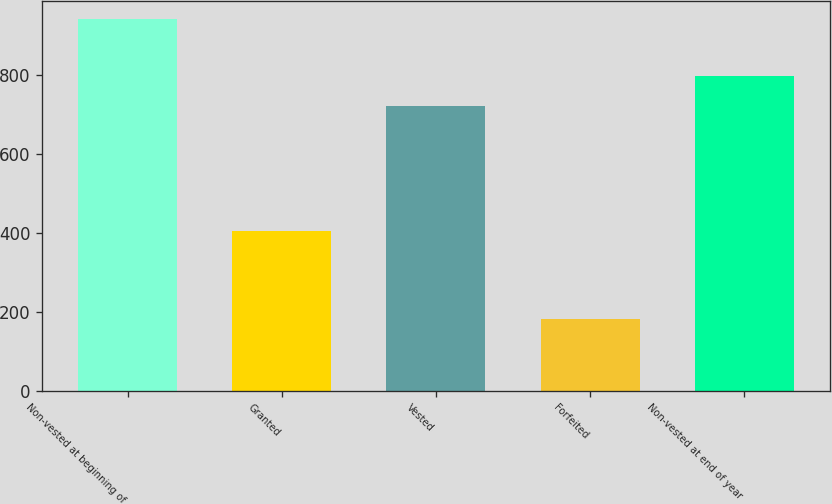Convert chart. <chart><loc_0><loc_0><loc_500><loc_500><bar_chart><fcel>Non-vested at beginning of<fcel>Granted<fcel>Vested<fcel>Forfeited<fcel>Non-vested at end of year<nl><fcel>941<fcel>404<fcel>721<fcel>182<fcel>796.9<nl></chart> 